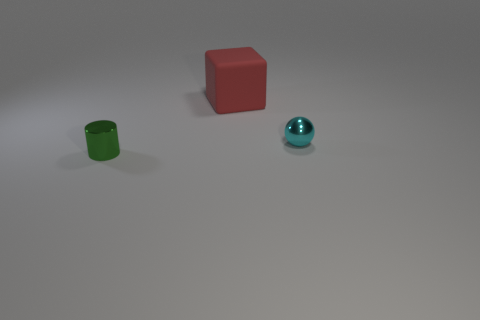Is there anything else that has the same size as the red block?
Make the answer very short. No. Are there any other things that are made of the same material as the large cube?
Keep it short and to the point. No. Are there any small green shiny cylinders on the right side of the small cyan ball?
Provide a short and direct response. No. Are there an equal number of rubber objects to the right of the green metal object and tiny green metal things?
Provide a short and direct response. Yes. There is a tiny object that is left of the metallic object to the right of the shiny cylinder; is there a tiny green cylinder right of it?
Provide a short and direct response. No. What is the material of the cylinder?
Offer a terse response. Metal. How many other objects are there of the same shape as the red object?
Make the answer very short. 0. Is the shape of the cyan metal thing the same as the large matte thing?
Keep it short and to the point. No. How many objects are either shiny objects that are in front of the cyan thing or metallic things that are on the left side of the cyan sphere?
Your response must be concise. 1. How many things are either spheres or matte objects?
Keep it short and to the point. 2. 